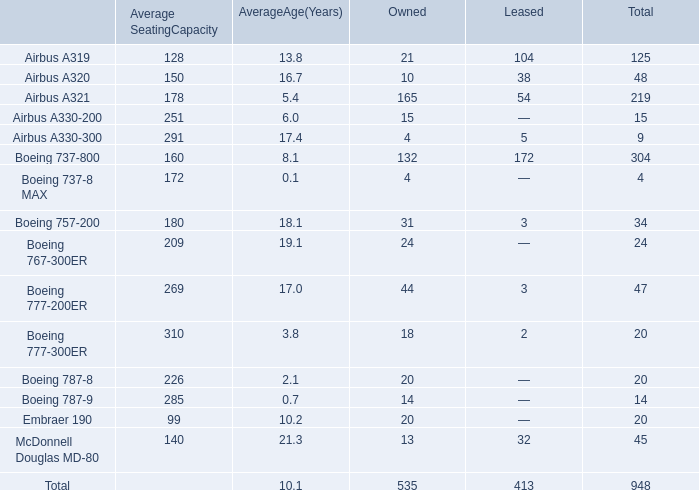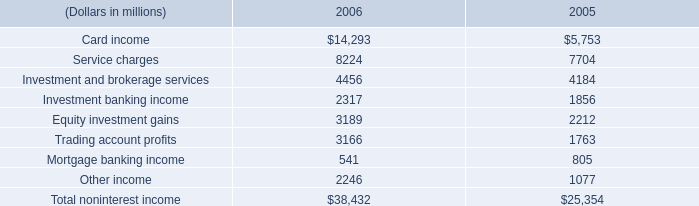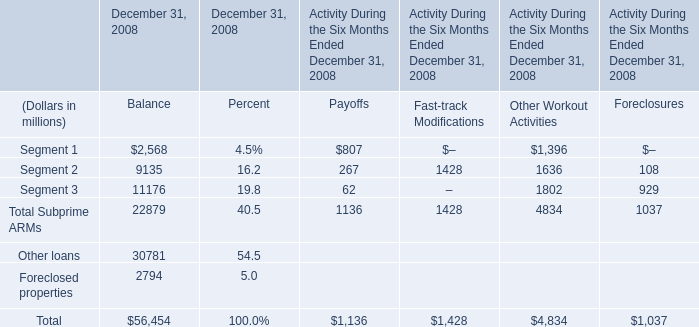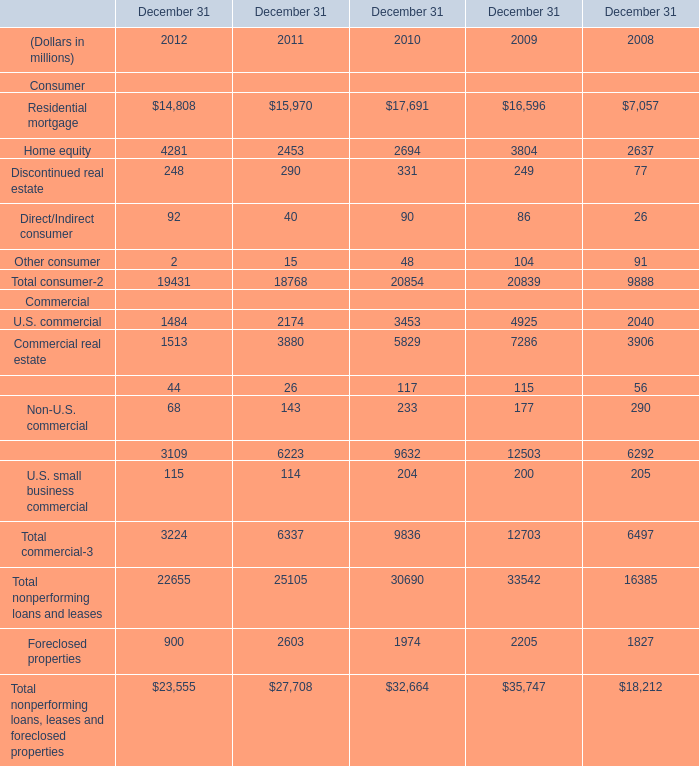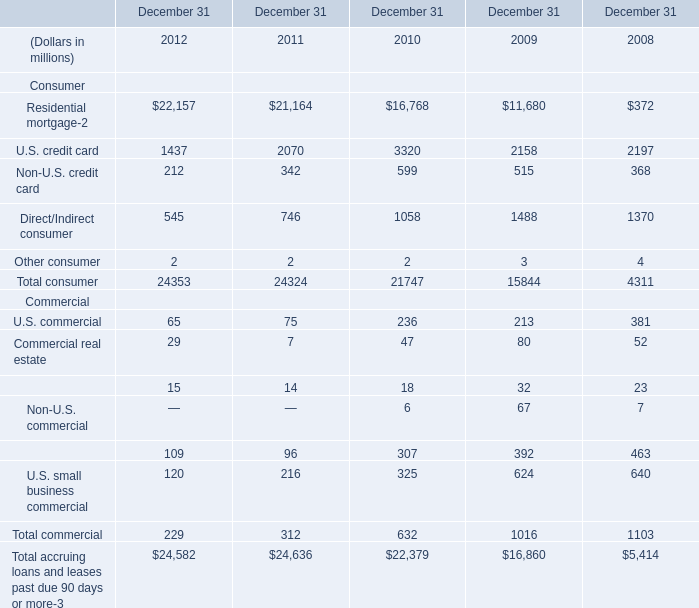In the year with the most Total consumer, what is the growth rate of U.S. commercial? 
Computations: ((65 - 75) / 65)
Answer: -0.15385. 